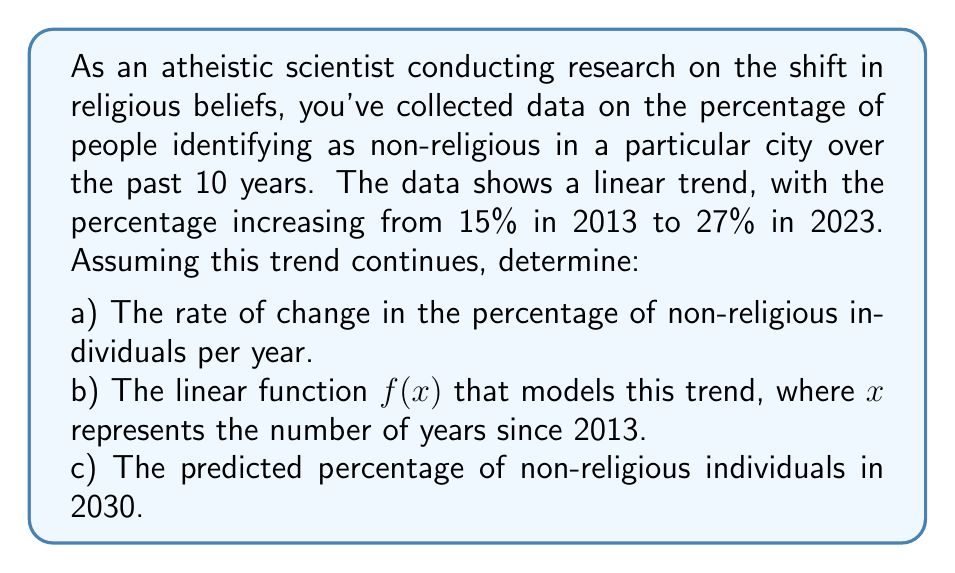Help me with this question. Let's approach this step-by-step:

a) To find the rate of change, we use the slope formula:

$$\text{Rate of change} = \frac{\text{Change in y}}{\text{Change in x}} = \frac{y_2 - y_1}{x_2 - x_1}$$

Where $(x_1, y_1)$ is (0, 15) for 2013 and $(x_2, y_2)$ is (10, 27) for 2023.

$$\text{Rate of change} = \frac{27 - 15}{10 - 0} = \frac{12}{10} = 1.2\% \text{ per year}$$

b) To find the linear function, we use the point-slope form:

$$f(x) = m(x - x_1) + y_1$$

Where $m$ is the rate of change (slope) we just calculated, and $(x_1, y_1)$ is our initial point (0, 15).

$$f(x) = 1.2(x - 0) + 15$$
$$f(x) = 1.2x + 15$$

c) To predict the percentage in 2030, we need to calculate $f(17)$ since 2030 is 17 years after 2013:

$$f(17) = 1.2(17) + 15 = 20.4 + 15 = 35.4\%$$
Answer: a) The rate of change is 1.2% per year.
b) The linear function is $f(x) = 1.2x + 15$, where $x$ is the number of years since 2013.
c) The predicted percentage of non-religious individuals in 2030 is 35.4%. 